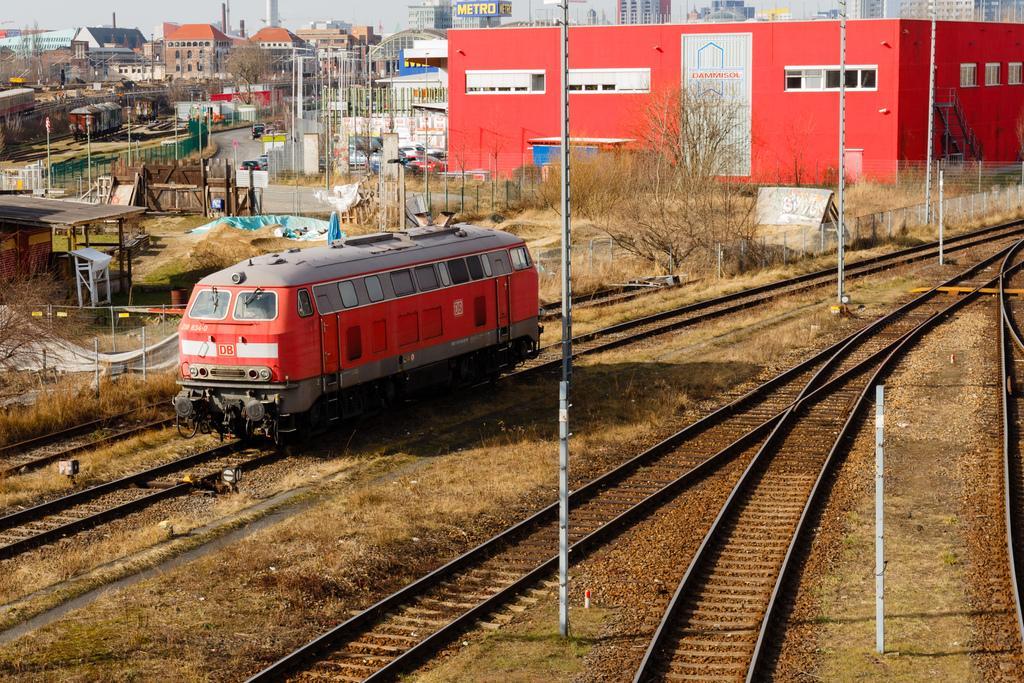Describe this image in one or two sentences. In this image there are trains present on the railway track. Image also consists of trees, poles and also many buildings. Some vehicles and road and also fence are visible in this image. 